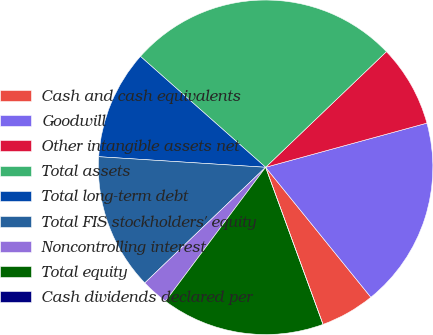Convert chart to OTSL. <chart><loc_0><loc_0><loc_500><loc_500><pie_chart><fcel>Cash and cash equivalents<fcel>Goodwill<fcel>Other intangible assets net<fcel>Total assets<fcel>Total long-term debt<fcel>Total FIS stockholders' equity<fcel>Noncontrolling interest<fcel>Total equity<fcel>Cash dividends declared per<nl><fcel>5.26%<fcel>18.42%<fcel>7.9%<fcel>26.31%<fcel>10.53%<fcel>13.16%<fcel>2.63%<fcel>15.79%<fcel>0.0%<nl></chart> 